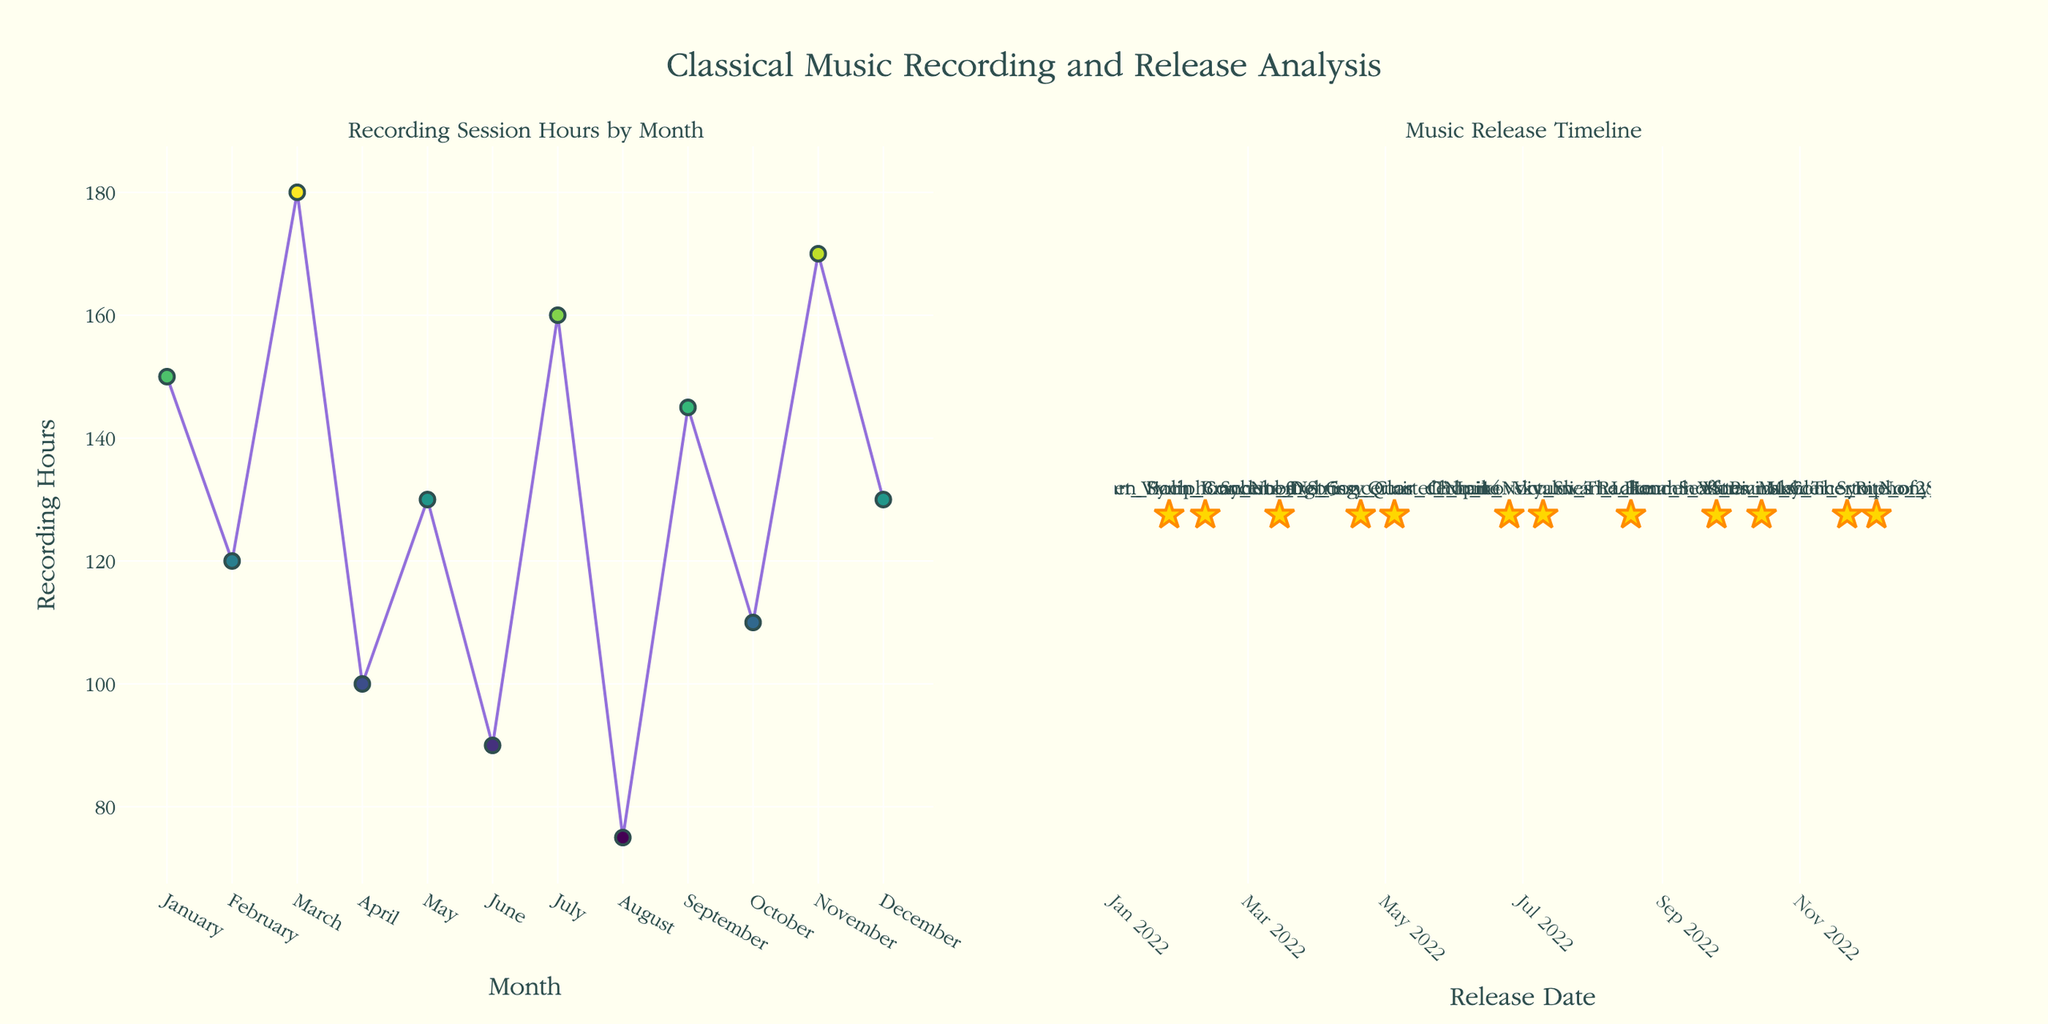What's the title of the figure? The title is displayed at the top center of the figure.
Answer: "Classical Music Recording and Release Analysis" How many months show a recording session below 100 hours? Looking at the left subplot, only April and August have recording session hours below 100.
Answer: 2 months Which month had the highest number of recording session hours? According to the scatter plot on the left, March had 180 hours, which is the highest.
Answer: March What is the color scale used for recording session hours? The color scale for the markers ranges, as described by the colors visible in the points.
Answer: Viridis When was "Tchaikovsky_Swan_Lake" released? In the right subplot, the star marker labeled "Tchaikovsky_Swan_Lake" aligns with July 10, 2022.
Answer: July 10, 2022 What is the difference in recording hours between June and July? June has 90 hours and July has 160 hours. The difference is calculated as 160 - 90.
Answer: 70 hours Which album was released the earliest in 2022? "Beethoven_Symphony_No_9" was released on January 25, 2022, as seen on the right subplot.
Answer: Beethoven_Symphony_No_9 Does November have more recording hours than May? November has 170 hours and May has 130 hours, so November has more.
Answer: Yes Which month has the least number of recording session hours? The scatter plot on the left indicates August has 75 hours, which is the lowest.
Answer: August What symbols are used to mark the album releases on the timeline? The right subplot uses star symbols to mark the album releases.
Answer: Stars 